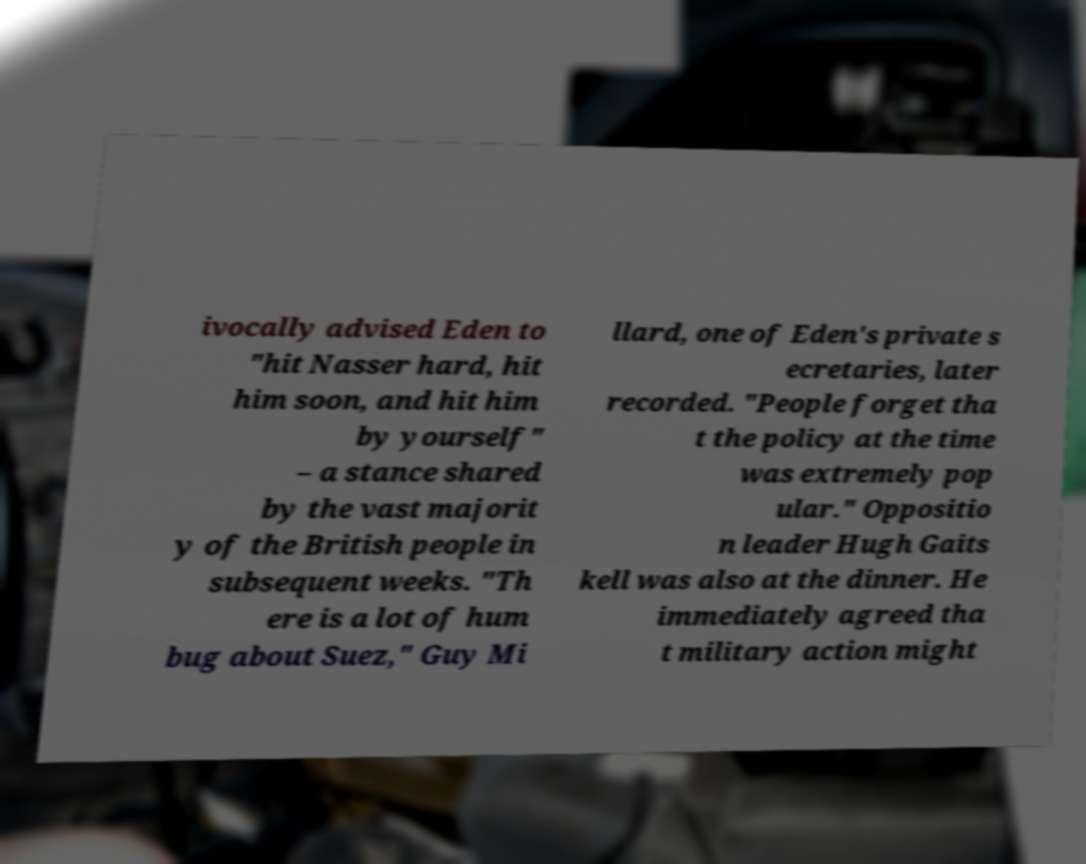I need the written content from this picture converted into text. Can you do that? ivocally advised Eden to "hit Nasser hard, hit him soon, and hit him by yourself" – a stance shared by the vast majorit y of the British people in subsequent weeks. "Th ere is a lot of hum bug about Suez," Guy Mi llard, one of Eden's private s ecretaries, later recorded. "People forget tha t the policy at the time was extremely pop ular." Oppositio n leader Hugh Gaits kell was also at the dinner. He immediately agreed tha t military action might 